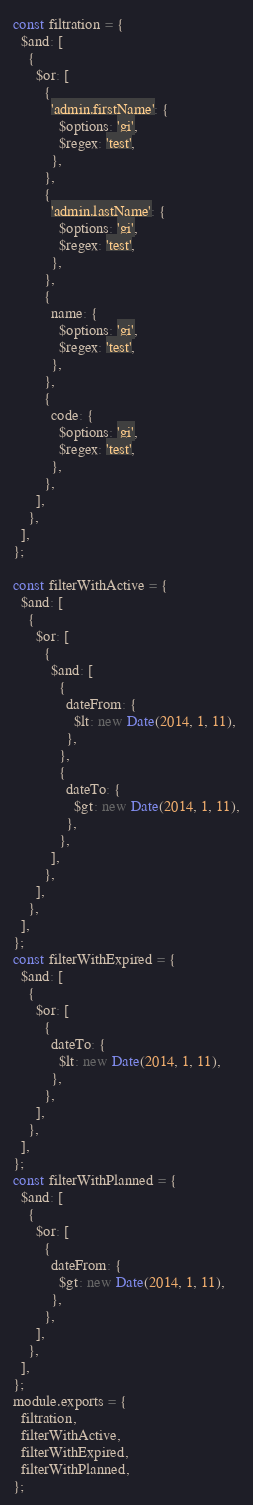Convert code to text. <code><loc_0><loc_0><loc_500><loc_500><_JavaScript_>const filtration = {
  $and: [
    {
      $or: [
        {
          'admin.firstName': {
            $options: 'gi',
            $regex: 'test',
          },
        },
        {
          'admin.lastName': {
            $options: 'gi',
            $regex: 'test',
          },
        },
        {
          name: {
            $options: 'gi',
            $regex: 'test',
          },
        },
        {
          code: {
            $options: 'gi',
            $regex: 'test',
          },
        },
      ],
    },
  ],
};

const filterWithActive = {
  $and: [
    {
      $or: [
        {
          $and: [
            {
              dateFrom: {
                $lt: new Date(2014, 1, 11),
              },
            },
            {
              dateTo: {
                $gt: new Date(2014, 1, 11),
              },
            },
          ],
        },
      ],
    },
  ],
};
const filterWithExpired = {
  $and: [
    {
      $or: [
        {
          dateTo: {
            $lt: new Date(2014, 1, 11),
          },
        },
      ],
    },
  ],
};
const filterWithPlanned = {
  $and: [
    {
      $or: [
        {
          dateFrom: {
            $gt: new Date(2014, 1, 11),
          },
        },
      ],
    },
  ],
};
module.exports = {
  filtration,
  filterWithActive,
  filterWithExpired,
  filterWithPlanned,
};
</code> 